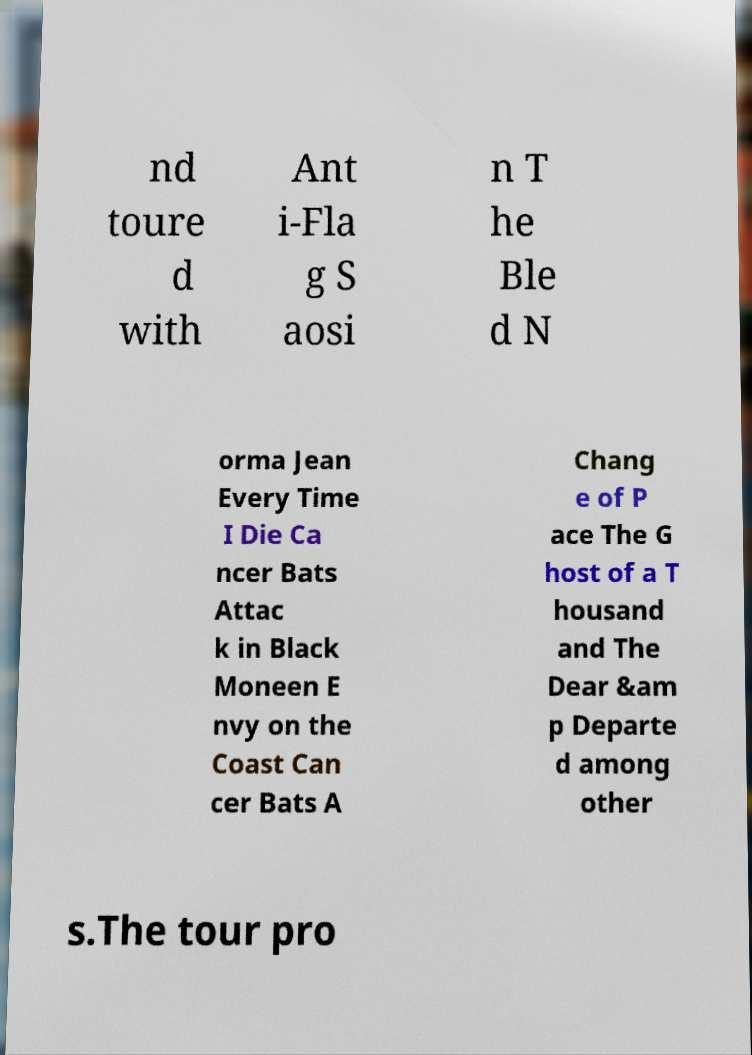There's text embedded in this image that I need extracted. Can you transcribe it verbatim? nd toure d with Ant i-Fla g S aosi n T he Ble d N orma Jean Every Time I Die Ca ncer Bats Attac k in Black Moneen E nvy on the Coast Can cer Bats A Chang e of P ace The G host of a T housand and The Dear &am p Departe d among other s.The tour pro 